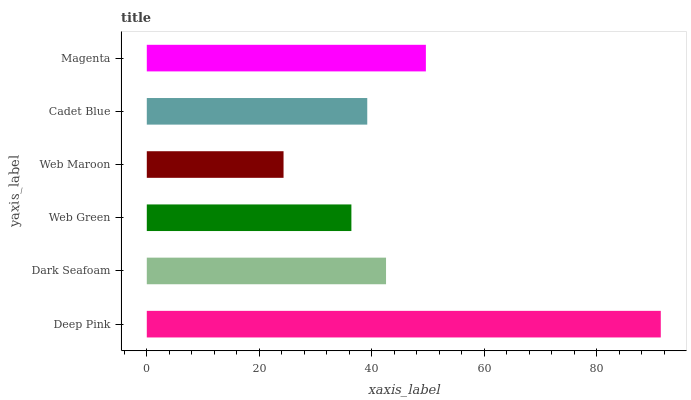Is Web Maroon the minimum?
Answer yes or no. Yes. Is Deep Pink the maximum?
Answer yes or no. Yes. Is Dark Seafoam the minimum?
Answer yes or no. No. Is Dark Seafoam the maximum?
Answer yes or no. No. Is Deep Pink greater than Dark Seafoam?
Answer yes or no. Yes. Is Dark Seafoam less than Deep Pink?
Answer yes or no. Yes. Is Dark Seafoam greater than Deep Pink?
Answer yes or no. No. Is Deep Pink less than Dark Seafoam?
Answer yes or no. No. Is Dark Seafoam the high median?
Answer yes or no. Yes. Is Cadet Blue the low median?
Answer yes or no. Yes. Is Magenta the high median?
Answer yes or no. No. Is Web Maroon the low median?
Answer yes or no. No. 